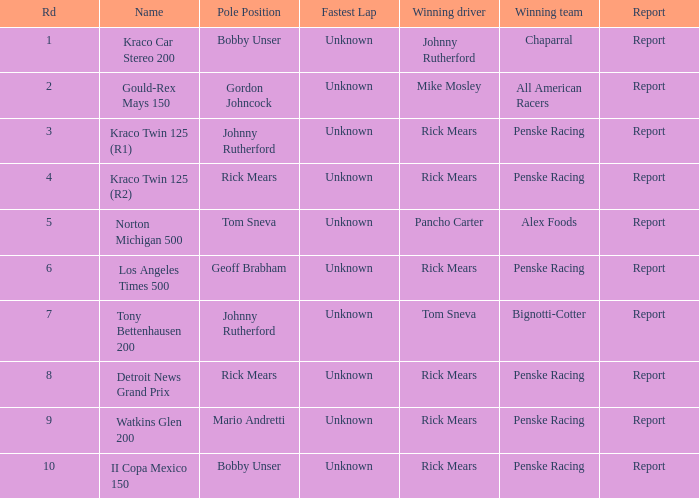Who is the victorious team in the los angeles times 500 race? Penske Racing. 